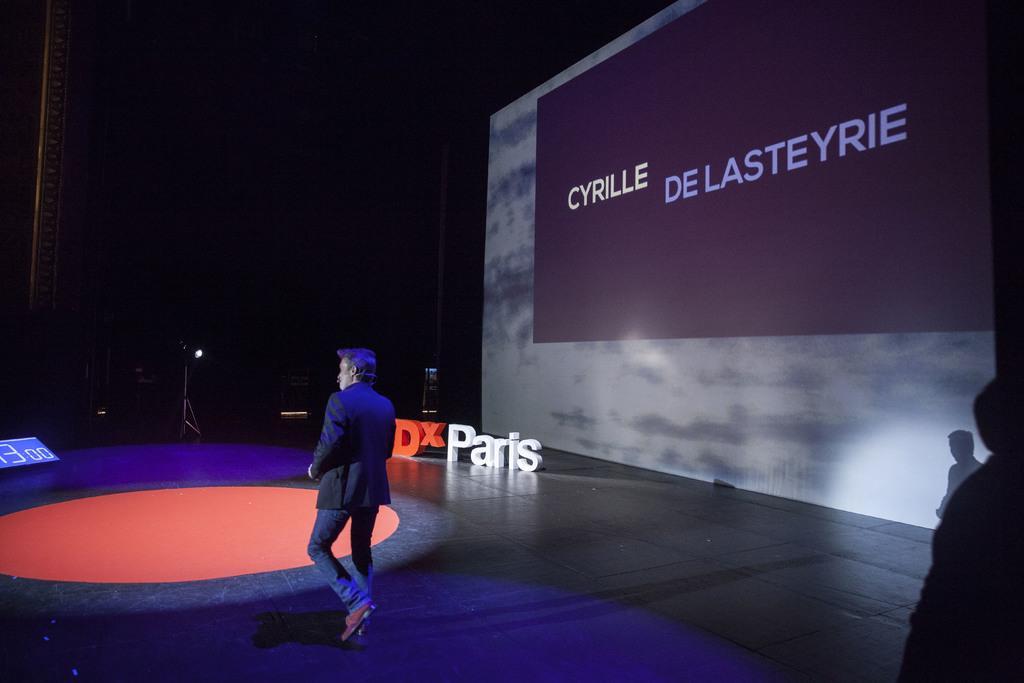Could you give a brief overview of what you see in this image? In this image I can see the person wearing the blaze and the pant. To the side of the person I can see the board and the screen. To the right I can see the shadow of the person. And there is a black background. 